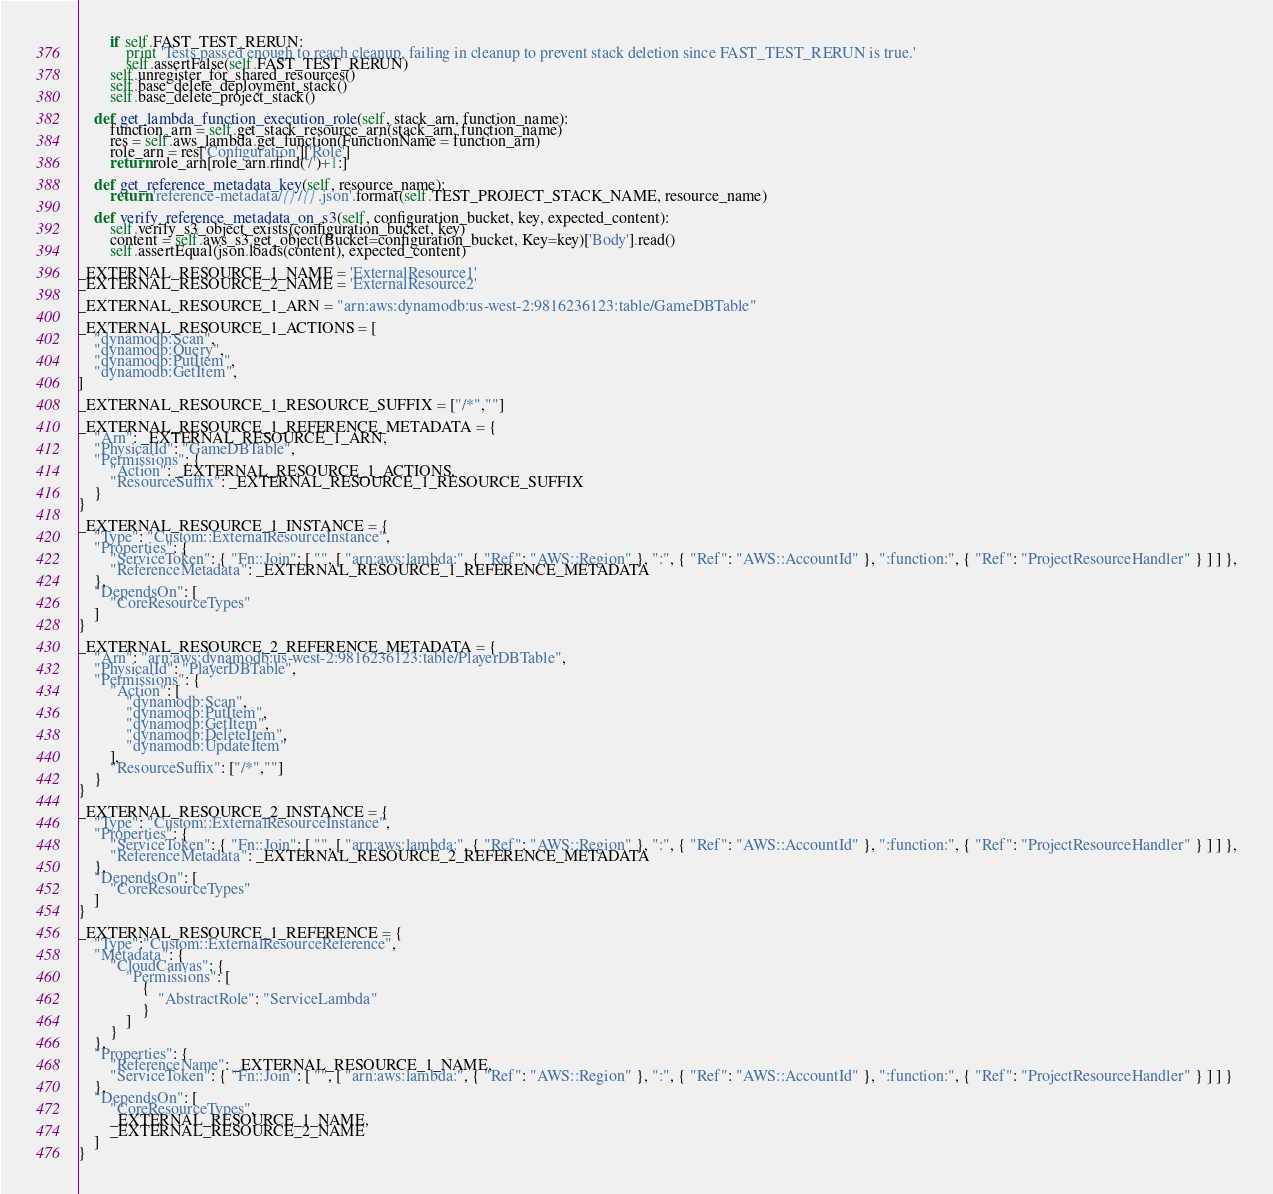<code> <loc_0><loc_0><loc_500><loc_500><_Python_>        if self.FAST_TEST_RERUN:
            print 'Tests passed enough to reach cleanup, failing in cleanup to prevent stack deletion since FAST_TEST_RERUN is true.'
            self.assertFalse(self.FAST_TEST_RERUN)
        self.unregister_for_shared_resources()
        self.base_delete_deployment_stack()
        self.base_delete_project_stack()

    def get_lambda_function_execution_role(self, stack_arn, function_name):
        function_arn = self.get_stack_resource_arn(stack_arn, function_name)
        res = self.aws_lambda.get_function(FunctionName = function_arn)
        role_arn = res['Configuration']['Role']
        return role_arn[role_arn.rfind('/')+1:]

    def get_reference_metadata_key(self, resource_name):
        return 'reference-metadata/{}/{}.json'.format(self.TEST_PROJECT_STACK_NAME, resource_name)

    def verify_reference_metadata_on_s3(self, configuration_bucket, key, expected_content):
        self.verify_s3_object_exists(configuration_bucket, key)
        content = self.aws_s3.get_object(Bucket=configuration_bucket, Key=key)['Body'].read()
        self.assertEqual(json.loads(content), expected_content)

_EXTERNAL_RESOURCE_1_NAME = 'ExternalResource1'
_EXTERNAL_RESOURCE_2_NAME = 'ExternalResource2'

_EXTERNAL_RESOURCE_1_ARN = "arn:aws:dynamodb:us-west-2:9816236123:table/GameDBTable"

_EXTERNAL_RESOURCE_1_ACTIONS = [
    "dynamodb:Scan",
    "dynamodb:Query",
    "dynamodb:PutItem",
    "dynamodb:GetItem",
]

_EXTERNAL_RESOURCE_1_RESOURCE_SUFFIX = ["/*",""]

_EXTERNAL_RESOURCE_1_REFERENCE_METADATA = {
    "Arn": _EXTERNAL_RESOURCE_1_ARN,
    "PhysicalId": "GameDBTable",
    "Permissions": {
        "Action": _EXTERNAL_RESOURCE_1_ACTIONS,
        "ResourceSuffix": _EXTERNAL_RESOURCE_1_RESOURCE_SUFFIX
    }
}

_EXTERNAL_RESOURCE_1_INSTANCE = {
    "Type": "Custom::ExternalResourceInstance",
    "Properties": {
        "ServiceToken": { "Fn::Join": [ "", [ "arn:aws:lambda:", { "Ref": "AWS::Region" }, ":", { "Ref": "AWS::AccountId" }, ":function:", { "Ref": "ProjectResourceHandler" } ] ] },
        "ReferenceMetadata": _EXTERNAL_RESOURCE_1_REFERENCE_METADATA
    },
    "DependsOn": [
        "CoreResourceTypes"
    ]
}

_EXTERNAL_RESOURCE_2_REFERENCE_METADATA = {
    "Arn": "arn:aws:dynamodb:us-west-2:9816236123:table/PlayerDBTable",
    "PhysicalId": "PlayerDBTable",
    "Permissions": {
        "Action": [
            "dynamodb:Scan",
            "dynamodb:PutItem",
            "dynamodb:GetItem",
            "dynamodb:DeleteItem",
            "dynamodb:UpdateItem"
        ],
        "ResourceSuffix": ["/*",""]
    }
}

_EXTERNAL_RESOURCE_2_INSTANCE = {
    "Type": "Custom::ExternalResourceInstance",
    "Properties": {
        "ServiceToken": { "Fn::Join": [ "", [ "arn:aws:lambda:", { "Ref": "AWS::Region" }, ":", { "Ref": "AWS::AccountId" }, ":function:", { "Ref": "ProjectResourceHandler" } ] ] },
        "ReferenceMetadata": _EXTERNAL_RESOURCE_2_REFERENCE_METADATA
    },
    "DependsOn": [
        "CoreResourceTypes"
    ]
}

_EXTERNAL_RESOURCE_1_REFERENCE = {
    "Type":"Custom::ExternalResourceReference",
    "Metadata": {
        "CloudCanvas": {
            "Permissions": [
                {
                    "AbstractRole": "ServiceLambda"
                }
            ]
        }
    },
    "Properties": {
        "ReferenceName": _EXTERNAL_RESOURCE_1_NAME,
        "ServiceToken": { "Fn::Join": [ "", [ "arn:aws:lambda:", { "Ref": "AWS::Region" }, ":", { "Ref": "AWS::AccountId" }, ":function:", { "Ref": "ProjectResourceHandler" } ] ] }
    },
    "DependsOn": [
        "CoreResourceTypes",
        _EXTERNAL_RESOURCE_1_NAME,
        _EXTERNAL_RESOURCE_2_NAME
    ]
}
</code> 